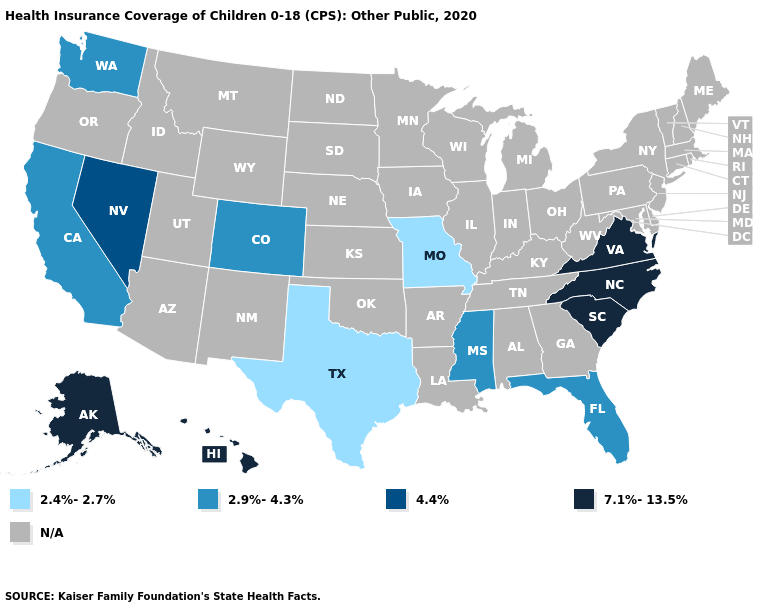What is the value of Florida?
Keep it brief. 2.9%-4.3%. Which states hav the highest value in the MidWest?
Short answer required. Missouri. What is the value of Nevada?
Answer briefly. 4.4%. What is the highest value in the West ?
Keep it brief. 7.1%-13.5%. Which states have the lowest value in the USA?
Quick response, please. Missouri, Texas. Name the states that have a value in the range N/A?
Short answer required. Alabama, Arizona, Arkansas, Connecticut, Delaware, Georgia, Idaho, Illinois, Indiana, Iowa, Kansas, Kentucky, Louisiana, Maine, Maryland, Massachusetts, Michigan, Minnesota, Montana, Nebraska, New Hampshire, New Jersey, New Mexico, New York, North Dakota, Ohio, Oklahoma, Oregon, Pennsylvania, Rhode Island, South Dakota, Tennessee, Utah, Vermont, West Virginia, Wisconsin, Wyoming. Name the states that have a value in the range 2.4%-2.7%?
Write a very short answer. Missouri, Texas. What is the value of Hawaii?
Concise answer only. 7.1%-13.5%. Does the first symbol in the legend represent the smallest category?
Write a very short answer. Yes. 